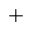Convert formula to latex. <formula><loc_0><loc_0><loc_500><loc_500>+</formula> 